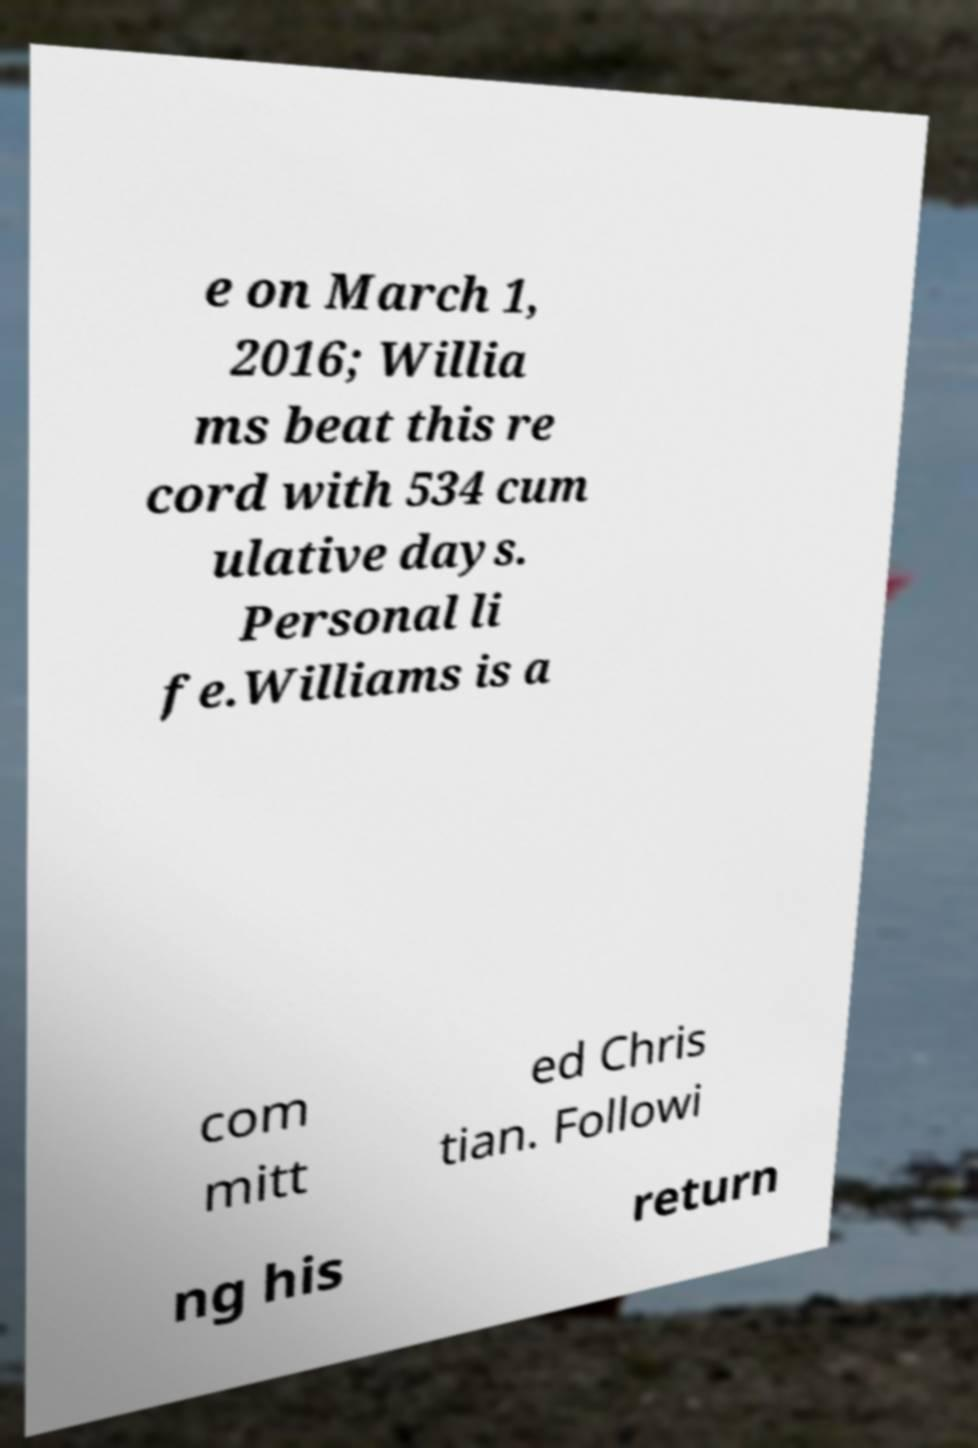Could you extract and type out the text from this image? e on March 1, 2016; Willia ms beat this re cord with 534 cum ulative days. Personal li fe.Williams is a com mitt ed Chris tian. Followi ng his return 